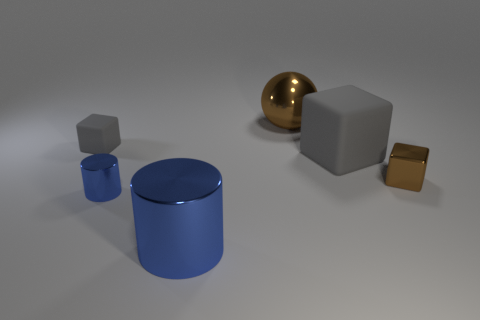What is the size of the object that is both behind the tiny blue cylinder and to the left of the big metal sphere?
Give a very brief answer. Small. Is the number of tiny blue metallic cylinders less than the number of blue matte cubes?
Your answer should be very brief. No. There is a brown object to the right of the large brown metallic thing; what size is it?
Your answer should be very brief. Small. What is the shape of the tiny thing that is on the left side of the large ball and on the right side of the small gray cube?
Offer a terse response. Cylinder. What size is the other brown thing that is the same shape as the small matte object?
Your answer should be very brief. Small. What number of tiny brown objects have the same material as the big brown ball?
Your answer should be very brief. 1. There is a shiny cube; is it the same color as the thing that is behind the tiny rubber object?
Make the answer very short. Yes. Is the number of shiny cylinders greater than the number of red blocks?
Make the answer very short. Yes. The big matte block is what color?
Offer a very short reply. Gray. Do the cylinder that is in front of the tiny metallic cylinder and the tiny metal cylinder have the same color?
Keep it short and to the point. Yes. 